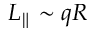<formula> <loc_0><loc_0><loc_500><loc_500>L _ { \| } \sim q R</formula> 